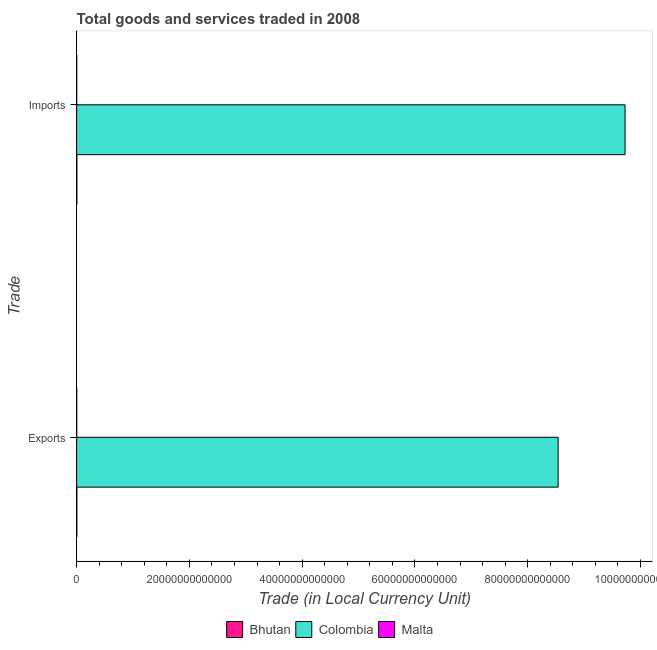How many different coloured bars are there?
Keep it short and to the point. 3. How many groups of bars are there?
Make the answer very short. 2. Are the number of bars per tick equal to the number of legend labels?
Ensure brevity in your answer.  Yes. How many bars are there on the 2nd tick from the top?
Provide a short and direct response. 3. What is the label of the 1st group of bars from the top?
Keep it short and to the point. Imports. What is the export of goods and services in Malta?
Your answer should be very brief. 5.13e+09. Across all countries, what is the maximum export of goods and services?
Provide a short and direct response. 8.54e+13. Across all countries, what is the minimum imports of goods and services?
Make the answer very short. 5.21e+09. In which country was the imports of goods and services maximum?
Make the answer very short. Colombia. In which country was the export of goods and services minimum?
Give a very brief answer. Malta. What is the total export of goods and services in the graph?
Ensure brevity in your answer.  8.54e+13. What is the difference between the imports of goods and services in Malta and that in Colombia?
Provide a short and direct response. -9.73e+13. What is the difference between the imports of goods and services in Malta and the export of goods and services in Bhutan?
Provide a succinct answer. -2.03e+1. What is the average imports of goods and services per country?
Give a very brief answer. 3.24e+13. What is the difference between the imports of goods and services and export of goods and services in Malta?
Provide a succinct answer. 8.77e+07. In how many countries, is the imports of goods and services greater than 64000000000000 LCU?
Your answer should be compact. 1. What is the ratio of the imports of goods and services in Malta to that in Colombia?
Your answer should be very brief. 5.3596907831164294e-5. Is the imports of goods and services in Colombia less than that in Bhutan?
Ensure brevity in your answer.  No. What does the 3rd bar from the bottom in Imports represents?
Your answer should be very brief. Malta. How many bars are there?
Provide a succinct answer. 6. How many countries are there in the graph?
Offer a terse response. 3. What is the difference between two consecutive major ticks on the X-axis?
Keep it short and to the point. 2.00e+13. Are the values on the major ticks of X-axis written in scientific E-notation?
Your answer should be compact. No. Where does the legend appear in the graph?
Ensure brevity in your answer.  Bottom center. What is the title of the graph?
Keep it short and to the point. Total goods and services traded in 2008. What is the label or title of the X-axis?
Ensure brevity in your answer.  Trade (in Local Currency Unit). What is the label or title of the Y-axis?
Provide a succinct answer. Trade. What is the Trade (in Local Currency Unit) in Bhutan in Exports?
Make the answer very short. 2.55e+1. What is the Trade (in Local Currency Unit) in Colombia in Exports?
Offer a terse response. 8.54e+13. What is the Trade (in Local Currency Unit) of Malta in Exports?
Your answer should be very brief. 5.13e+09. What is the Trade (in Local Currency Unit) of Bhutan in Imports?
Your answer should be very brief. 3.16e+1. What is the Trade (in Local Currency Unit) in Colombia in Imports?
Give a very brief answer. 9.73e+13. What is the Trade (in Local Currency Unit) in Malta in Imports?
Your response must be concise. 5.21e+09. Across all Trade, what is the maximum Trade (in Local Currency Unit) of Bhutan?
Make the answer very short. 3.16e+1. Across all Trade, what is the maximum Trade (in Local Currency Unit) of Colombia?
Your answer should be compact. 9.73e+13. Across all Trade, what is the maximum Trade (in Local Currency Unit) of Malta?
Ensure brevity in your answer.  5.21e+09. Across all Trade, what is the minimum Trade (in Local Currency Unit) in Bhutan?
Ensure brevity in your answer.  2.55e+1. Across all Trade, what is the minimum Trade (in Local Currency Unit) in Colombia?
Provide a succinct answer. 8.54e+13. Across all Trade, what is the minimum Trade (in Local Currency Unit) of Malta?
Provide a short and direct response. 5.13e+09. What is the total Trade (in Local Currency Unit) of Bhutan in the graph?
Offer a terse response. 5.71e+1. What is the total Trade (in Local Currency Unit) in Colombia in the graph?
Keep it short and to the point. 1.83e+14. What is the total Trade (in Local Currency Unit) of Malta in the graph?
Provide a short and direct response. 1.03e+1. What is the difference between the Trade (in Local Currency Unit) in Bhutan in Exports and that in Imports?
Your answer should be very brief. -6.09e+09. What is the difference between the Trade (in Local Currency Unit) in Colombia in Exports and that in Imports?
Make the answer very short. -1.19e+13. What is the difference between the Trade (in Local Currency Unit) of Malta in Exports and that in Imports?
Give a very brief answer. -8.77e+07. What is the difference between the Trade (in Local Currency Unit) in Bhutan in Exports and the Trade (in Local Currency Unit) in Colombia in Imports?
Provide a short and direct response. -9.73e+13. What is the difference between the Trade (in Local Currency Unit) of Bhutan in Exports and the Trade (in Local Currency Unit) of Malta in Imports?
Your answer should be very brief. 2.03e+1. What is the difference between the Trade (in Local Currency Unit) in Colombia in Exports and the Trade (in Local Currency Unit) in Malta in Imports?
Make the answer very short. 8.54e+13. What is the average Trade (in Local Currency Unit) of Bhutan per Trade?
Offer a terse response. 2.85e+1. What is the average Trade (in Local Currency Unit) of Colombia per Trade?
Provide a succinct answer. 9.13e+13. What is the average Trade (in Local Currency Unit) of Malta per Trade?
Your response must be concise. 5.17e+09. What is the difference between the Trade (in Local Currency Unit) of Bhutan and Trade (in Local Currency Unit) of Colombia in Exports?
Keep it short and to the point. -8.54e+13. What is the difference between the Trade (in Local Currency Unit) in Bhutan and Trade (in Local Currency Unit) in Malta in Exports?
Provide a short and direct response. 2.04e+1. What is the difference between the Trade (in Local Currency Unit) in Colombia and Trade (in Local Currency Unit) in Malta in Exports?
Provide a short and direct response. 8.54e+13. What is the difference between the Trade (in Local Currency Unit) of Bhutan and Trade (in Local Currency Unit) of Colombia in Imports?
Offer a terse response. -9.72e+13. What is the difference between the Trade (in Local Currency Unit) in Bhutan and Trade (in Local Currency Unit) in Malta in Imports?
Offer a very short reply. 2.64e+1. What is the difference between the Trade (in Local Currency Unit) of Colombia and Trade (in Local Currency Unit) of Malta in Imports?
Keep it short and to the point. 9.73e+13. What is the ratio of the Trade (in Local Currency Unit) in Bhutan in Exports to that in Imports?
Your answer should be compact. 0.81. What is the ratio of the Trade (in Local Currency Unit) of Colombia in Exports to that in Imports?
Offer a terse response. 0.88. What is the ratio of the Trade (in Local Currency Unit) of Malta in Exports to that in Imports?
Keep it short and to the point. 0.98. What is the difference between the highest and the second highest Trade (in Local Currency Unit) in Bhutan?
Offer a very short reply. 6.09e+09. What is the difference between the highest and the second highest Trade (in Local Currency Unit) of Colombia?
Offer a terse response. 1.19e+13. What is the difference between the highest and the second highest Trade (in Local Currency Unit) of Malta?
Give a very brief answer. 8.77e+07. What is the difference between the highest and the lowest Trade (in Local Currency Unit) in Bhutan?
Your answer should be very brief. 6.09e+09. What is the difference between the highest and the lowest Trade (in Local Currency Unit) in Colombia?
Your answer should be compact. 1.19e+13. What is the difference between the highest and the lowest Trade (in Local Currency Unit) of Malta?
Offer a terse response. 8.77e+07. 